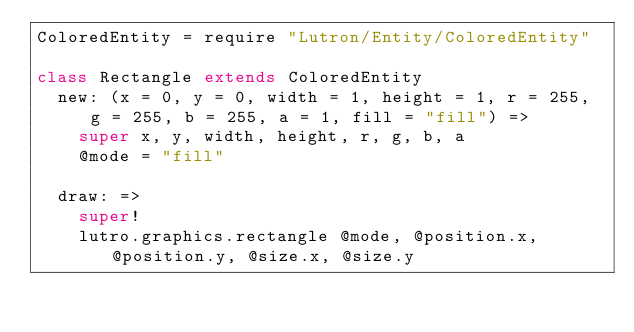Convert code to text. <code><loc_0><loc_0><loc_500><loc_500><_MoonScript_>ColoredEntity = require "Lutron/Entity/ColoredEntity"

class Rectangle extends ColoredEntity
  new: (x = 0, y = 0, width = 1, height = 1, r = 255, g = 255, b = 255, a = 1, fill = "fill") =>
    super x, y, width, height, r, g, b, a
    @mode = "fill"

  draw: =>
    super!
    lutro.graphics.rectangle @mode, @position.x, @position.y, @size.x, @size.y
</code> 